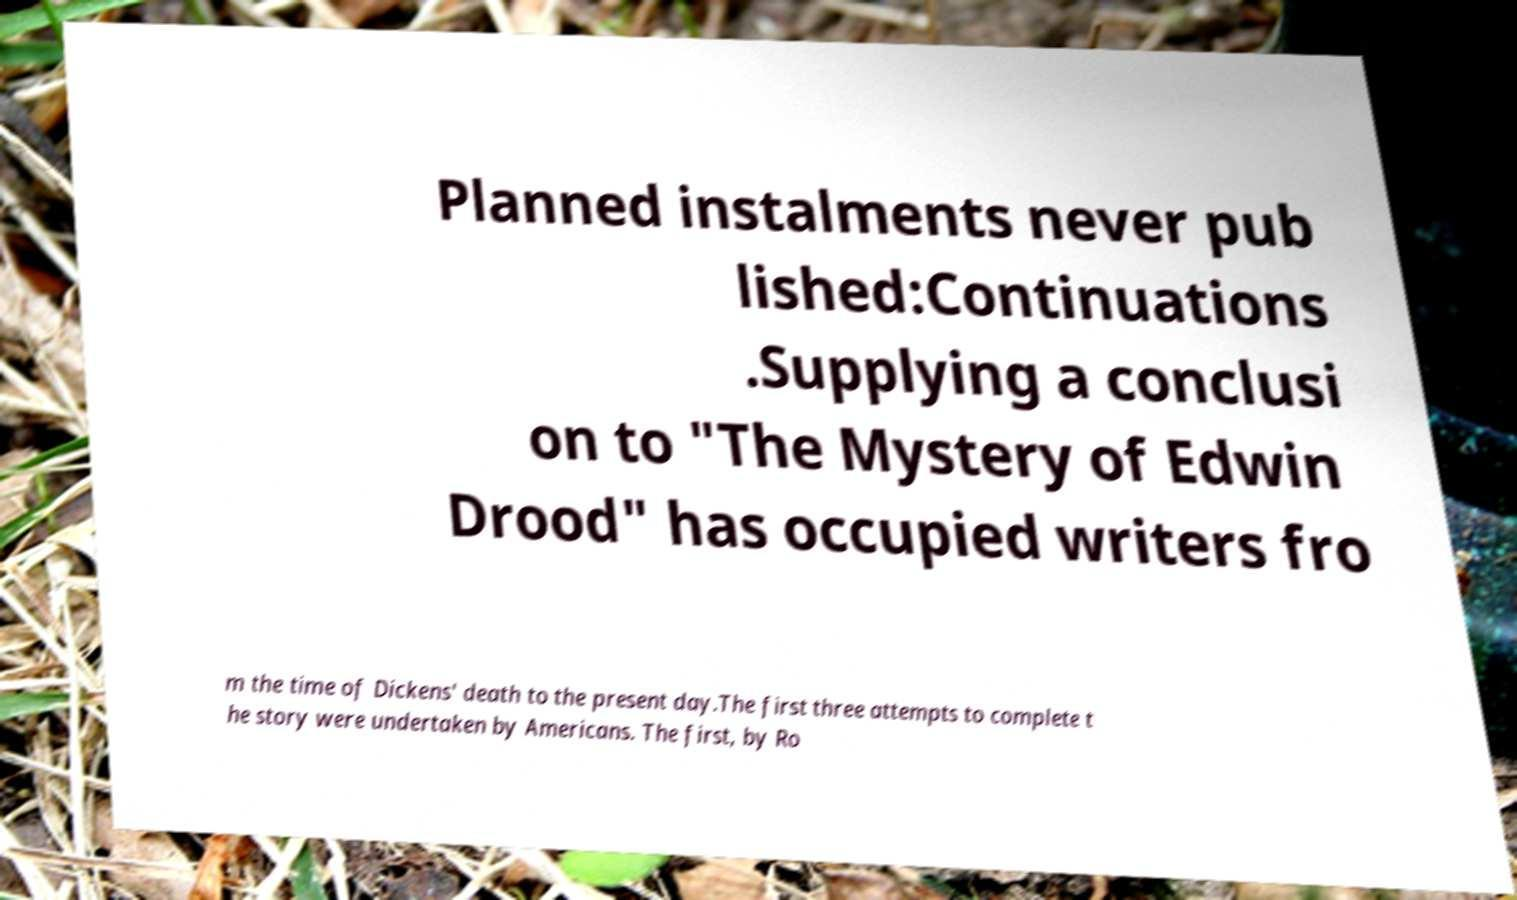Could you extract and type out the text from this image? Planned instalments never pub lished:Continuations .Supplying a conclusi on to "The Mystery of Edwin Drood" has occupied writers fro m the time of Dickens' death to the present day.The first three attempts to complete t he story were undertaken by Americans. The first, by Ro 